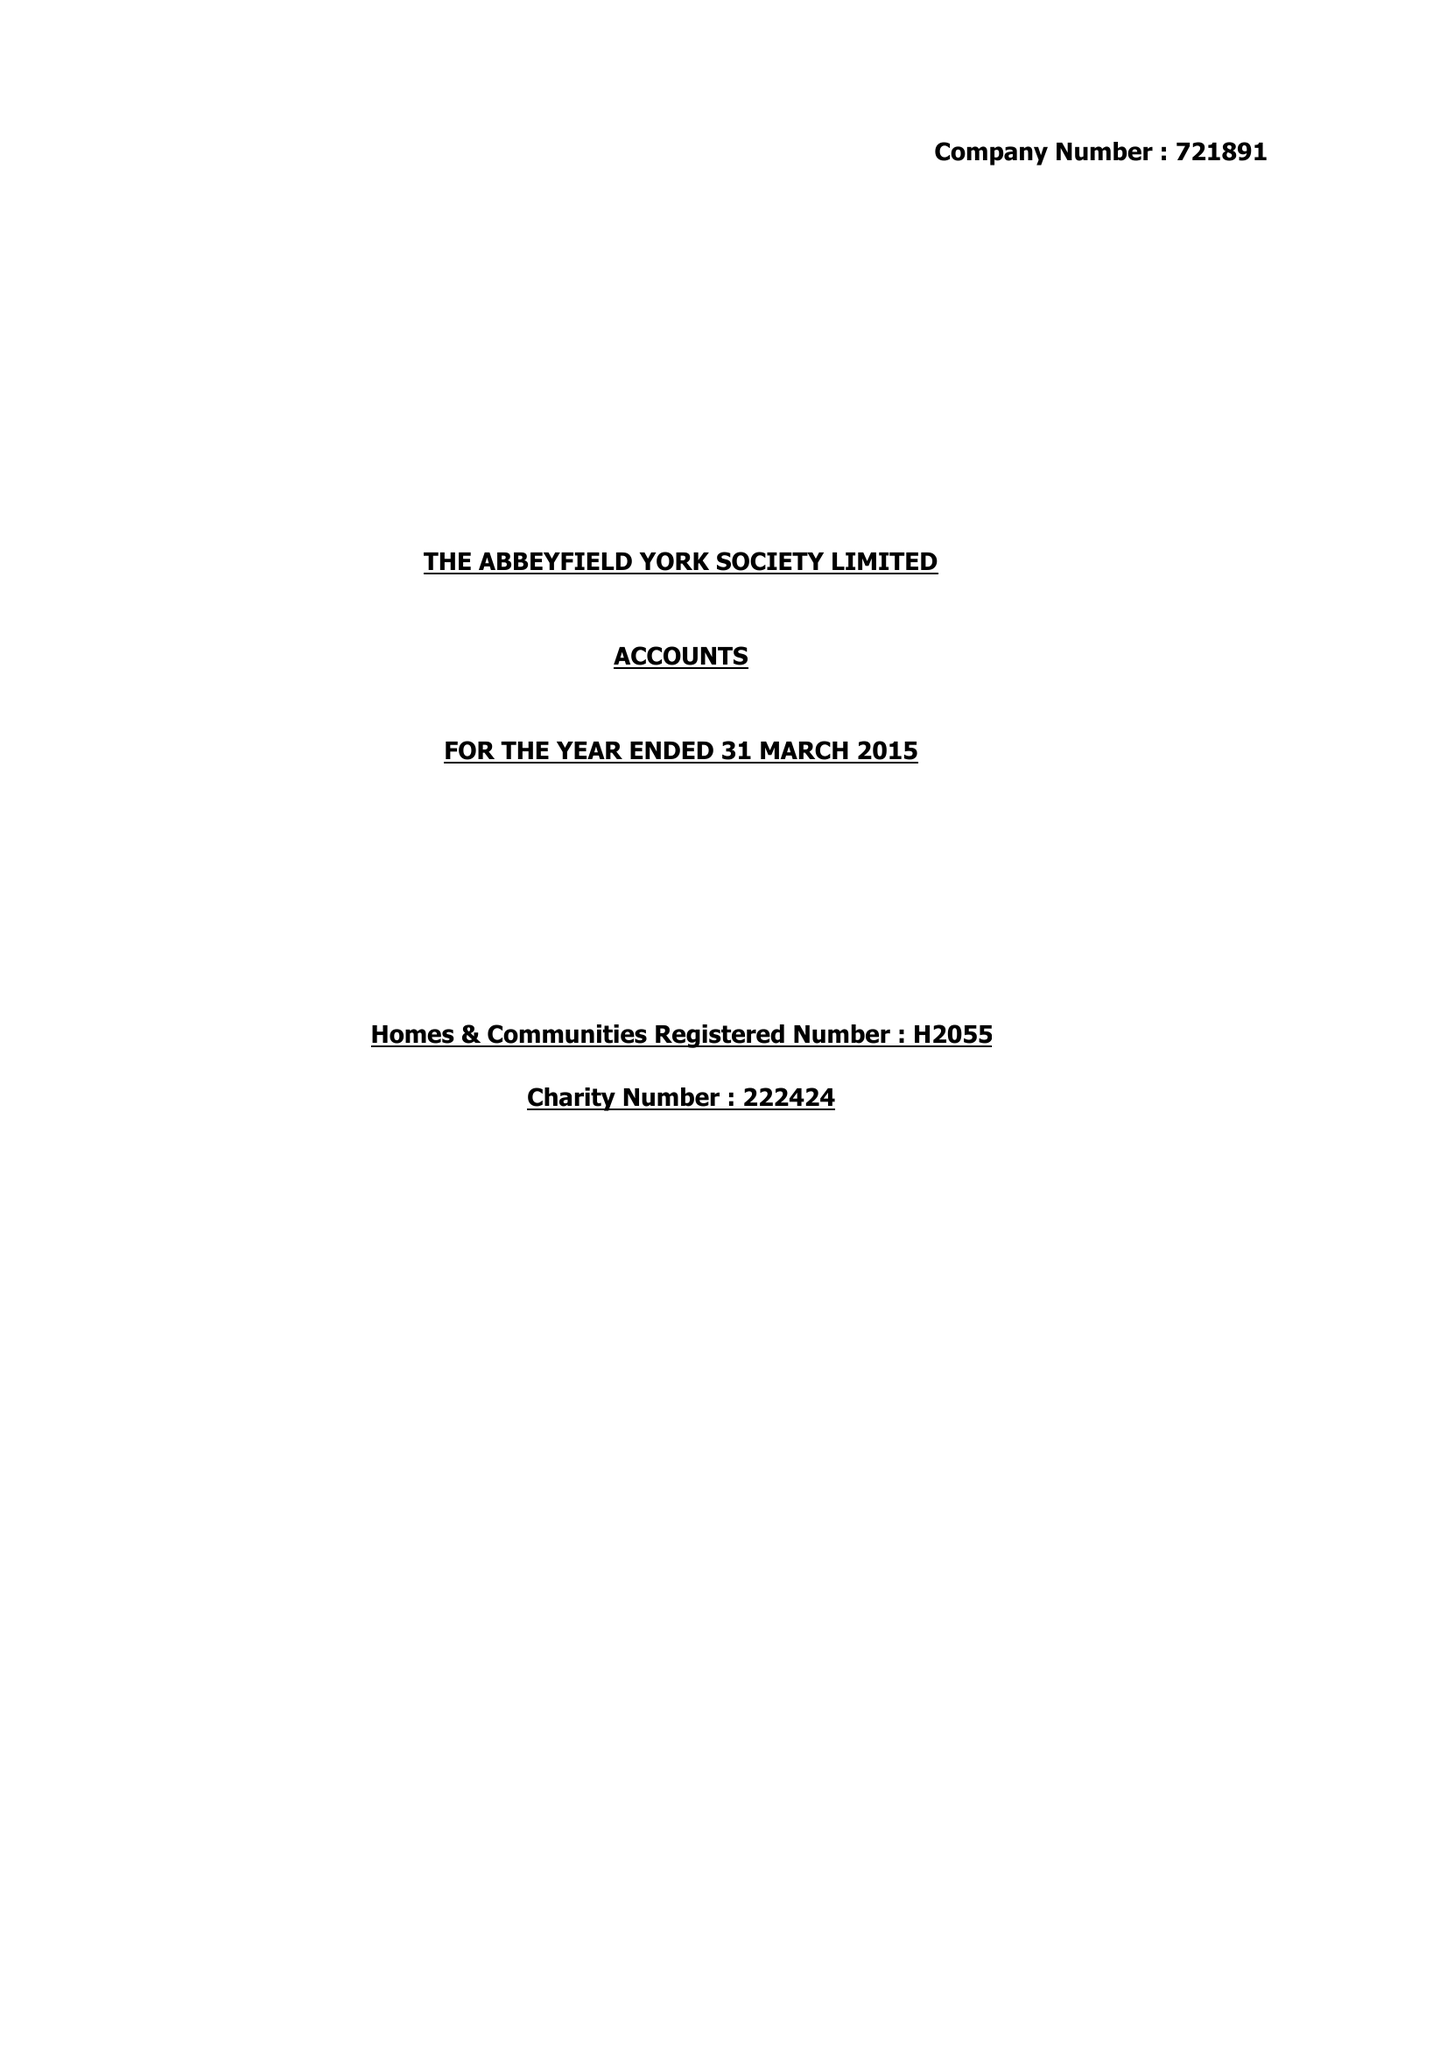What is the value for the address__post_town?
Answer the question using a single word or phrase. None 